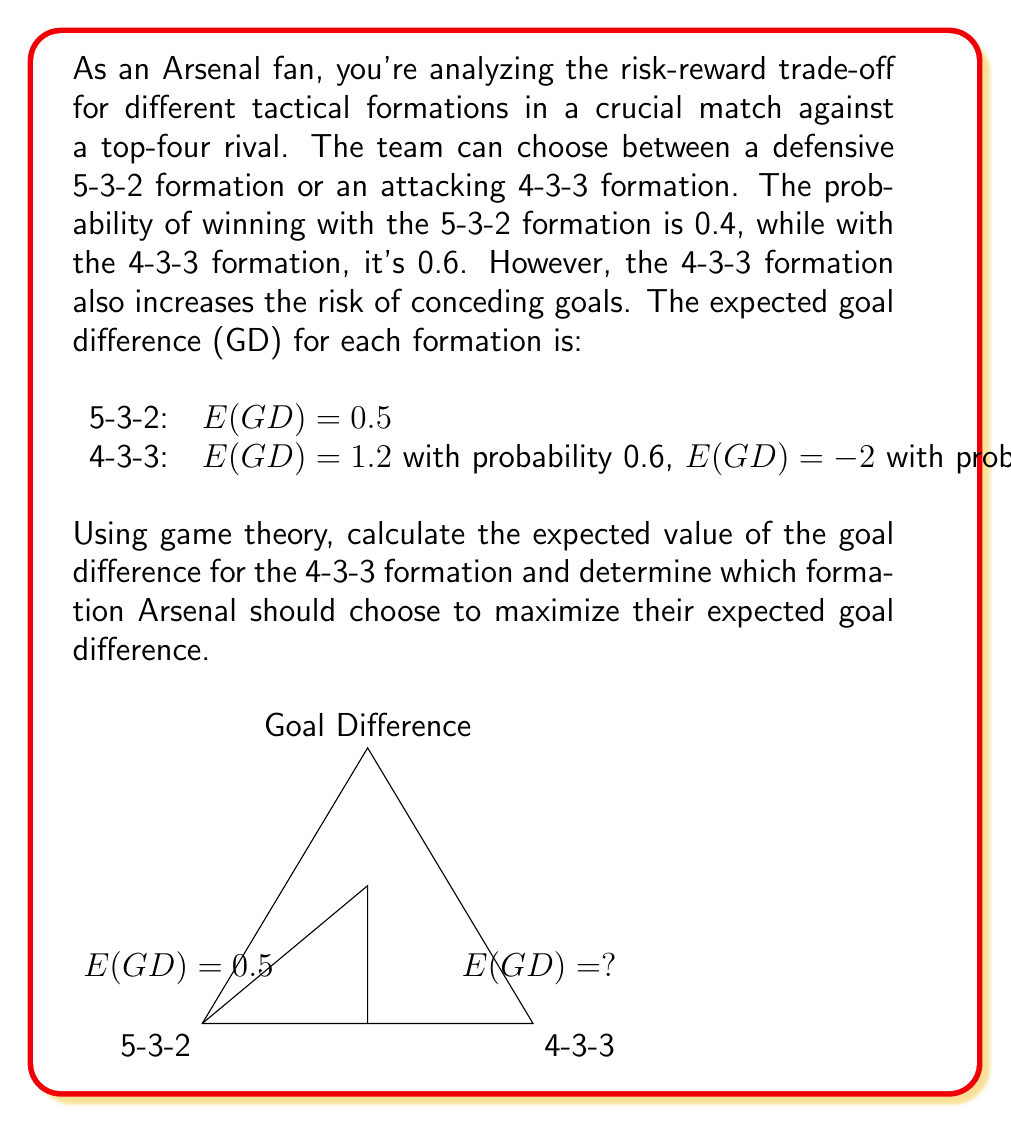Could you help me with this problem? Let's approach this step-by-step:

1) First, we need to calculate the expected value of the goal difference (E(GD)) for the 4-3-3 formation.

2) The expected value is the sum of each possible outcome multiplied by its probability:

   $E(GD_{4-3-3}) = 1.2 \cdot 0.6 + (-2) \cdot 0.4$

3) Let's calculate:
   
   $E(GD_{4-3-3}) = 0.72 - 0.8 = -0.08$

4) Now we can compare the expected goal differences:

   5-3-2 formation: $E(GD_{5-3-2}) = 0.5$
   4-3-3 formation: $E(GD_{4-3-3}) = -0.08$

5) To maximize the expected goal difference, Arsenal should choose the formation with the higher E(GD).

6) Since $0.5 > -0.08$, Arsenal should choose the 5-3-2 formation.

This decision aligns with the risk-averse nature of a "loyal but easily frustrated Arsenal fan", as it provides a positive expected goal difference and reduces the risk of conceding goals, which could lead to frustration.
Answer: Choose 5-3-2 formation; E(GD) = 0.5 